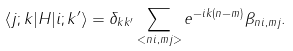Convert formula to latex. <formula><loc_0><loc_0><loc_500><loc_500>\langle j ; k | H | i ; k ^ { \prime } \rangle = \delta _ { k k ^ { \prime } } \sum _ { < n i , m j > } e ^ { - i k ( n - m ) } \beta _ { n i , m j } .</formula> 